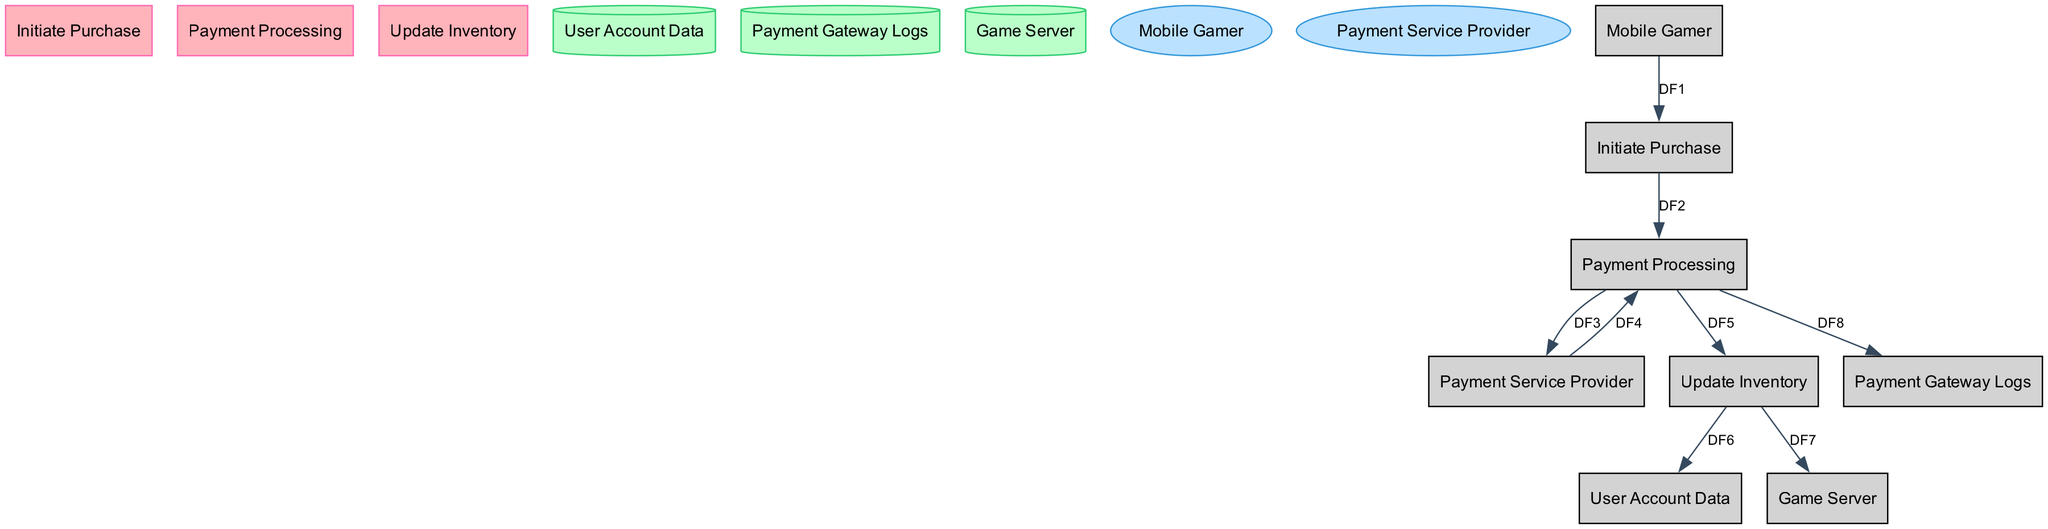What process does the gamer initiate first? The first action taken by the mobile gamer is to select an item to purchase from the in-game store, which is represented as the "Initiate Purchase" process in the diagram.
Answer: Initiate Purchase How many external entities are there in the diagram? The diagram contains two separate external entities, which are the "Mobile Gamer" and the "Payment Service Provider."
Answer: 2 What flow follows the "Payment Processing" process? After the "Payment Processing" process is completed, the next step is to send a success signal to the "Update Inventory" process to update the user's inventory.
Answer: Update Inventory What is stored in the "User Account Data"? The "User Account Data" data store maintains user information, including game progress, in-game currency, and purchased items.
Answer: User information Which data store logs transaction details? The "Payment Gateway Logs" data store specifically records all transaction details processed through the payment gateway during the purchasing process.
Answer: Payment Gateway Logs What does the "Payment Service Provider" provide back to the "Payment Processing"? The "Payment Service Provider" returns the transaction outcome—whether it is a success or a failure—back to the "Payment Processing" process for further updates.
Answer: Transaction outcome What is the role of the "Update Inventory" process after a successful transaction? After a successful payment, the "Update Inventory" process operates to add the purchased item to the user's account and notify the game server of the inventory changes in real time.
Answer: Update user inventory What type of diagram is represented? The diagram illustrates the flow of data involved in processing in-game purchases, characteristic of a Data Flow Diagram used to depict interactions between different processes and data stores.
Answer: Data Flow Diagram 